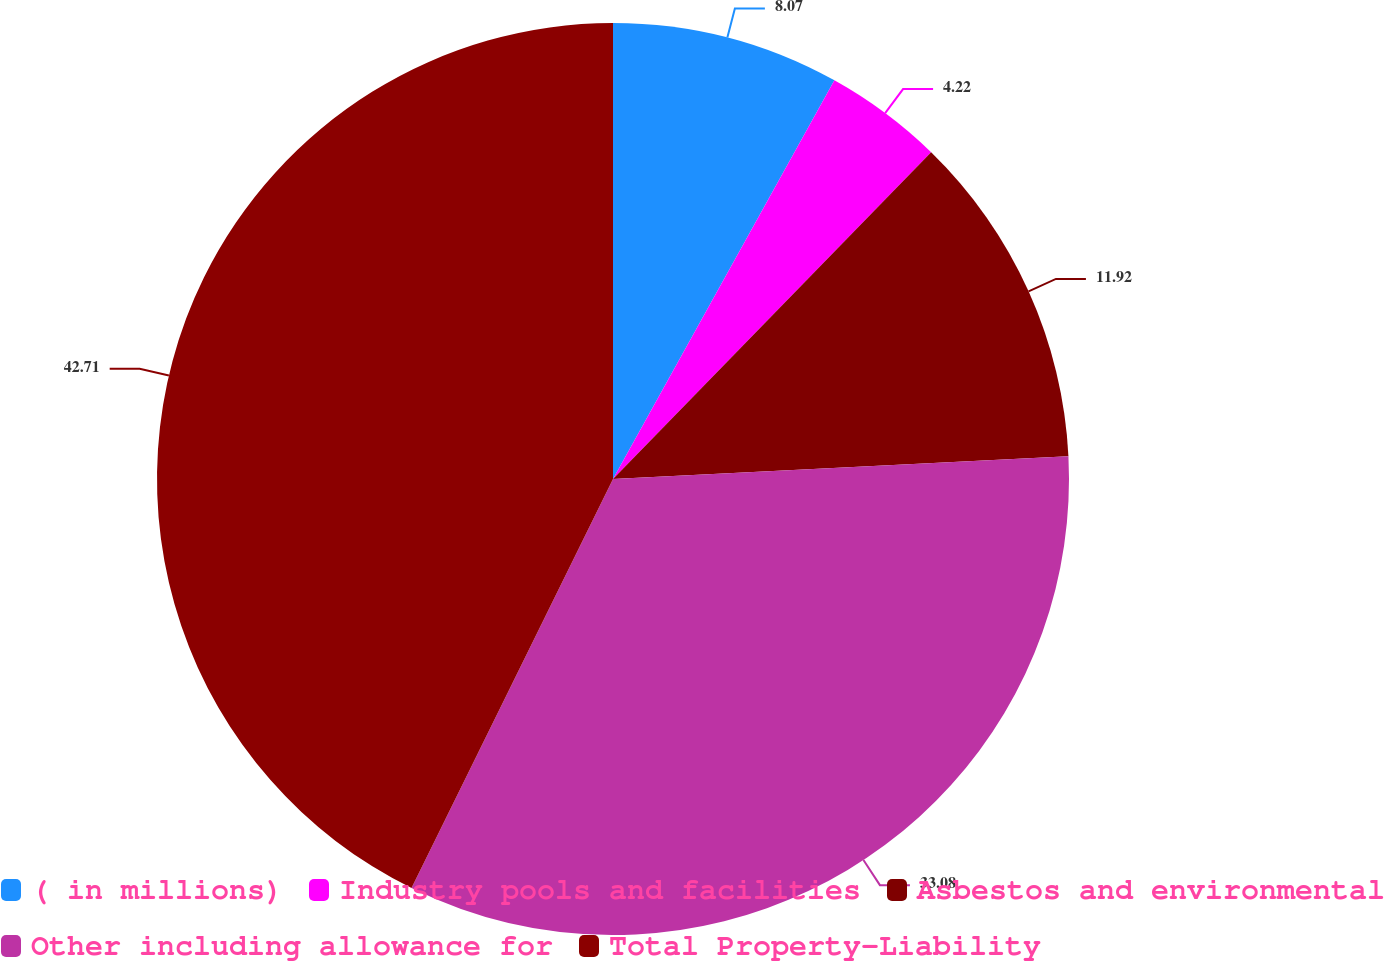Convert chart. <chart><loc_0><loc_0><loc_500><loc_500><pie_chart><fcel>( in millions)<fcel>Industry pools and facilities<fcel>Asbestos and environmental<fcel>Other including allowance for<fcel>Total Property-Liability<nl><fcel>8.07%<fcel>4.22%<fcel>11.92%<fcel>33.08%<fcel>42.72%<nl></chart> 